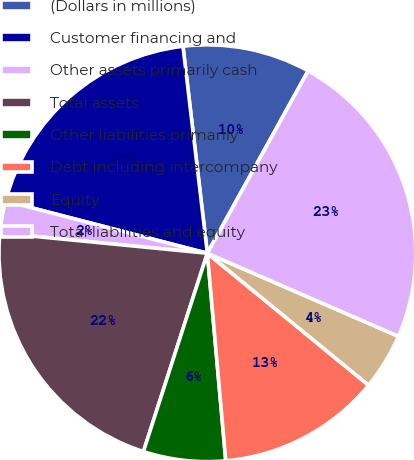Convert chart to OTSL. <chart><loc_0><loc_0><loc_500><loc_500><pie_chart><fcel>(Dollars in millions)<fcel>Customer financing and<fcel>Other assets primarily cash<fcel>Total assets<fcel>Other liabilities primarily<fcel>Debt including intercompany<fcel>Equity<fcel>Total liabilities and equity<nl><fcel>9.9%<fcel>19.1%<fcel>2.48%<fcel>21.58%<fcel>6.37%<fcel>12.67%<fcel>4.39%<fcel>23.49%<nl></chart> 